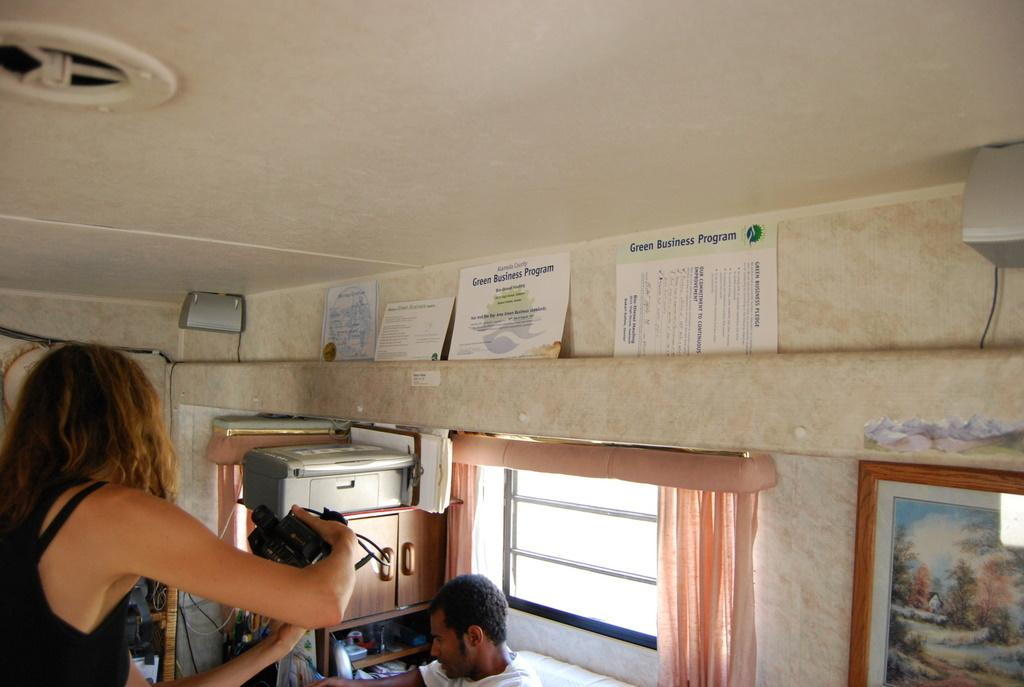Provide a one-sentence caption for the provided image. the top of a camper on the inside with a paper in it that says 'green business program' on it. 